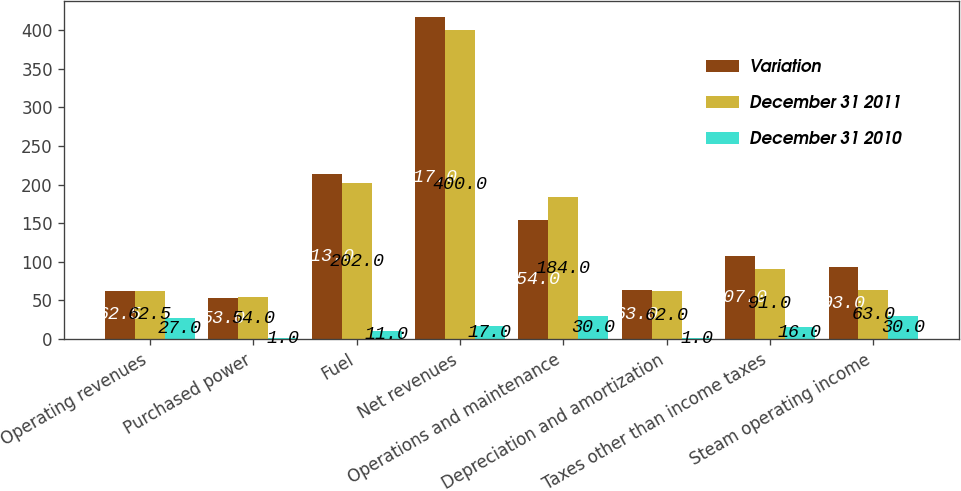Convert chart to OTSL. <chart><loc_0><loc_0><loc_500><loc_500><stacked_bar_chart><ecel><fcel>Operating revenues<fcel>Purchased power<fcel>Fuel<fcel>Net revenues<fcel>Operations and maintenance<fcel>Depreciation and amortization<fcel>Taxes other than income taxes<fcel>Steam operating income<nl><fcel>Variation<fcel>62.5<fcel>53<fcel>213<fcel>417<fcel>154<fcel>63<fcel>107<fcel>93<nl><fcel>December 31 2011<fcel>62.5<fcel>54<fcel>202<fcel>400<fcel>184<fcel>62<fcel>91<fcel>63<nl><fcel>December 31 2010<fcel>27<fcel>1<fcel>11<fcel>17<fcel>30<fcel>1<fcel>16<fcel>30<nl></chart> 